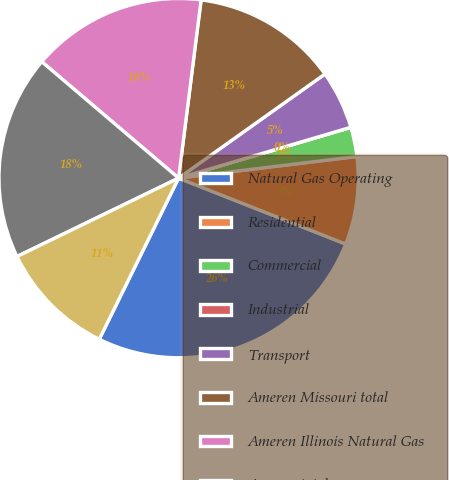Convert chart. <chart><loc_0><loc_0><loc_500><loc_500><pie_chart><fcel>Natural Gas Operating<fcel>Residential<fcel>Commercial<fcel>Industrial<fcel>Transport<fcel>Ameren Missouri total<fcel>Ameren Illinois Natural Gas<fcel>Ameren total<fcel>Transport and other<nl><fcel>26.3%<fcel>7.9%<fcel>2.64%<fcel>0.01%<fcel>5.27%<fcel>13.16%<fcel>15.78%<fcel>18.41%<fcel>10.53%<nl></chart> 